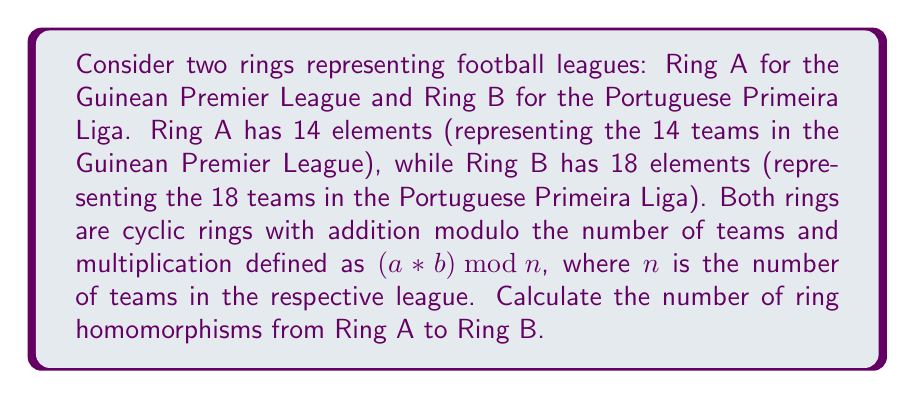Teach me how to tackle this problem. To solve this problem, we need to follow these steps:

1) First, recall that a ring homomorphism $f: A \to B$ must satisfy:
   a) $f(x + y) = f(x) + f(y)$ for all $x, y \in A$
   b) $f(xy) = f(x)f(y)$ for all $x, y \in A$
   c) $f(1_A) = 1_B$ if A has a multiplicative identity

2) In cyclic rings, all homomorphisms are determined by the image of the generator. Let's call the generator of Ring A as $g_A$.

3) The order of $g_A$ in Ring A is 14 (the number of elements in A).

4) For a homomorphism to exist, the image of $g_A$ in Ring B must have an order that divides 14.

5) The possible orders in Ring B that divide 14 are 1, 2, 7, and 14.

6) Now, we need to count how many elements in Ring B have these orders:
   - Order 1: Only the zero element (0)
   - Order 2: The element 9 (as $9 + 9 \equiv 0 \pmod{18}$)
   - Order 7: None (as 7 doesn't divide 18)
   - Order 14: None (as 14 doesn't divide 18)

7) Therefore, there are only two possible images for $g_A$: 0 and 9.

8) Each of these possibilities defines a unique ring homomorphism.

Thus, there are 2 ring homomorphisms from Ring A to Ring B.
Answer: 2 ring homomorphisms 